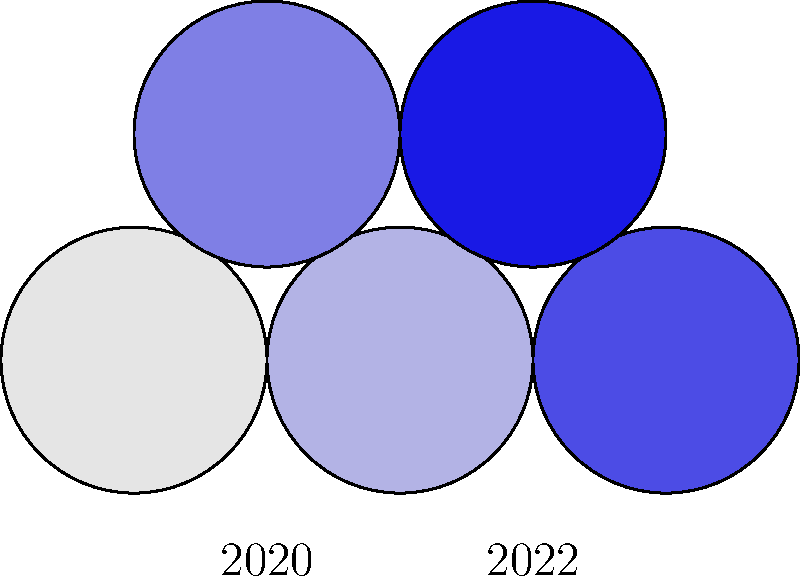The choropleth map shows demographic shifts in voting districts between 2020 and 2022. Darker shades of blue indicate a higher percentage of registered voters. Which district experienced the most significant increase in registered voters, and how might this impact election integrity measures? To answer this question, we need to analyze the choropleth map and understand its implications for election integrity:

1. Observe the color changes:
   - The map shows five districts, with 2020 on the left and 2022 on the right.
   - Darker shades of blue represent higher percentages of registered voters.

2. Identify the most significant change:
   - The rightmost district in 2022 has the darkest shade of blue.
   - This district was lighter in 2020, indicating a substantial increase in registered voters.

3. Implications for election integrity:
   - A sudden, significant increase in registered voters may raise concerns about:
     a) Potential voter registration fraud
     b) Accuracy of voter rolls
     c) Possible manipulation of district boundaries (gerrymandering)

4. Necessary measures to ensure election integrity:
   - Implement strict voter registration verification processes
   - Conduct regular audits of voter rolls
   - Investigate unusual patterns in voter registration increases
   - Ensure transparent redistricting processes

5. Impact on election procedures:
   - Increased need for poll workers and voting equipment
   - Potential for longer wait times at polling stations
   - Greater importance of efficient vote counting and reporting systems

The most significant increase in registered voters occurred in the rightmost district, which requires heightened scrutiny and robust election integrity measures to ensure a fair and accurate voting process.
Answer: Rightmost district; requires increased verification, audits, and resources to maintain election integrity. 